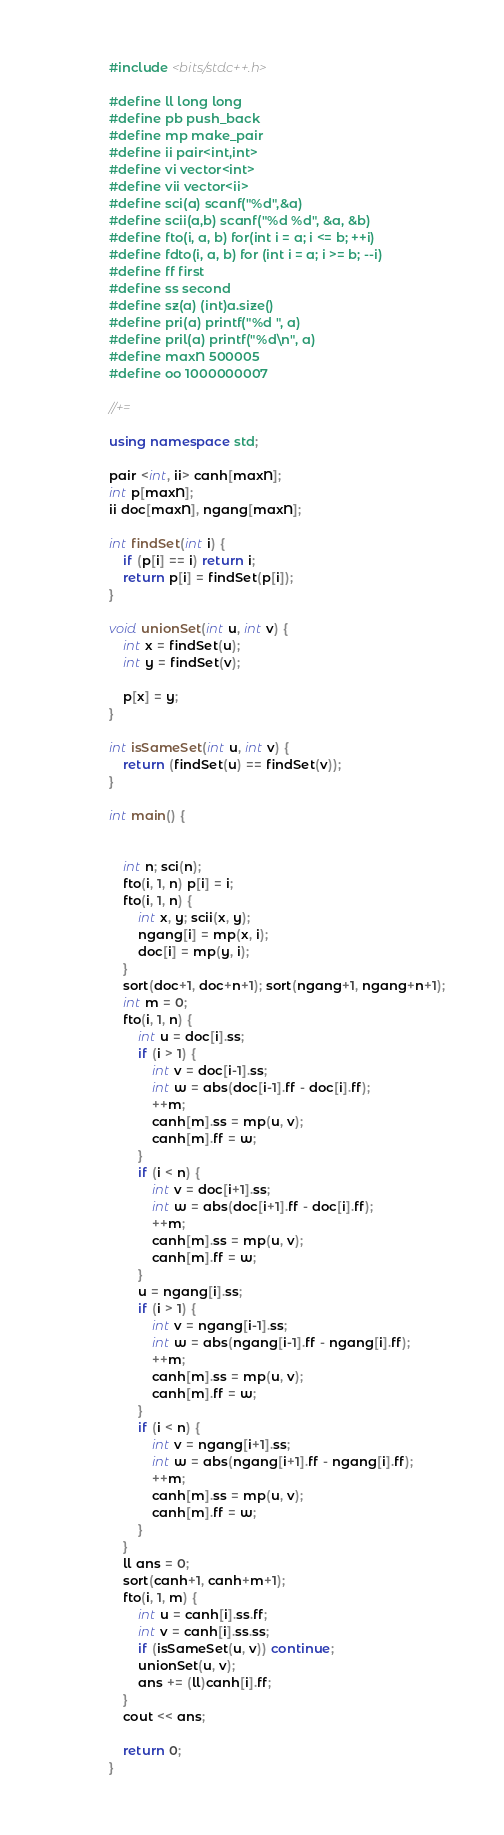Convert code to text. <code><loc_0><loc_0><loc_500><loc_500><_C++_>#include <bits/stdc++.h>

#define ll long long
#define pb push_back
#define mp make_pair
#define ii pair<int,int>
#define vi vector<int>
#define vii vector<ii>
#define sci(a) scanf("%d",&a)
#define scii(a,b) scanf("%d %d", &a, &b)
#define fto(i, a, b) for(int i = a; i <= b; ++i)
#define fdto(i, a, b) for (int i = a; i >= b; --i)
#define ff first
#define ss second
#define sz(a) (int)a.size()
#define pri(a) printf("%d ", a)
#define pril(a) printf("%d\n", a)
#define maxN 500005
#define oo 1000000007

//+=

using namespace std;

pair <int, ii> canh[maxN];
int p[maxN];
ii doc[maxN], ngang[maxN];

int findSet(int i) {
    if (p[i] == i) return i;
    return p[i] = findSet(p[i]);
}

void unionSet(int u, int v) {
    int x = findSet(u);
    int y = findSet(v);

    p[x] = y;
}

int isSameSet(int u, int v) {
    return (findSet(u) == findSet(v));
}

int main() {


    int n; sci(n);
    fto(i, 1, n) p[i] = i;
    fto(i, 1, n) {
        int x, y; scii(x, y);
        ngang[i] = mp(x, i);
        doc[i] = mp(y, i);
    }
    sort(doc+1, doc+n+1); sort(ngang+1, ngang+n+1);
    int m = 0;
    fto(i, 1, n) {
        int u = doc[i].ss;
        if (i > 1) {
            int v = doc[i-1].ss;
            int w = abs(doc[i-1].ff - doc[i].ff);
            ++m;
            canh[m].ss = mp(u, v);
            canh[m].ff = w;
        }
        if (i < n) {
            int v = doc[i+1].ss;
            int w = abs(doc[i+1].ff - doc[i].ff);
            ++m;
            canh[m].ss = mp(u, v);
            canh[m].ff = w;
        }
        u = ngang[i].ss;
        if (i > 1) {
            int v = ngang[i-1].ss;
            int w = abs(ngang[i-1].ff - ngang[i].ff);
            ++m;
            canh[m].ss = mp(u, v);
            canh[m].ff = w;
        }
        if (i < n) {
            int v = ngang[i+1].ss;
            int w = abs(ngang[i+1].ff - ngang[i].ff);
            ++m;
            canh[m].ss = mp(u, v);
            canh[m].ff = w;
        }
    }
    ll ans = 0;
    sort(canh+1, canh+m+1);
    fto(i, 1, m) {
        int u = canh[i].ss.ff;
        int v = canh[i].ss.ss;
        if (isSameSet(u, v)) continue;
        unionSet(u, v);
        ans += (ll)canh[i].ff;
    }
    cout << ans;

    return 0;
}

</code> 